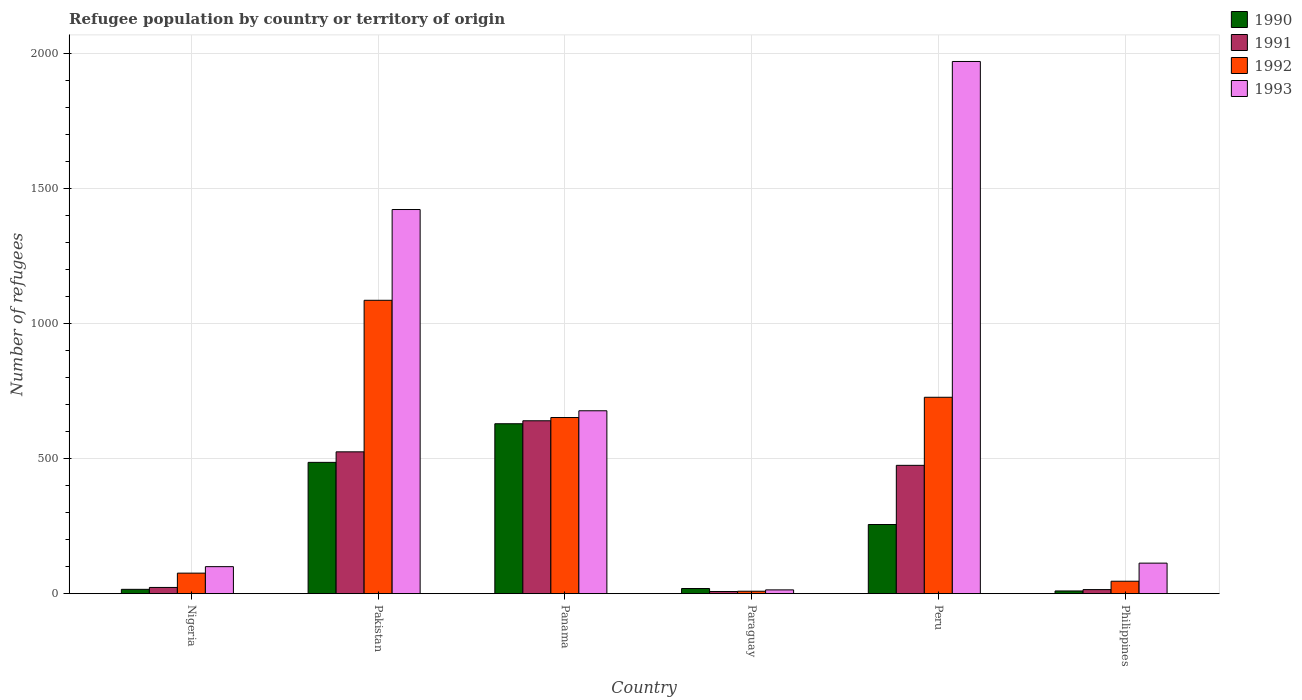How many bars are there on the 5th tick from the left?
Your answer should be very brief. 4. In how many cases, is the number of bars for a given country not equal to the number of legend labels?
Your answer should be very brief. 0. Across all countries, what is the maximum number of refugees in 1993?
Your answer should be compact. 1970. In which country was the number of refugees in 1992 maximum?
Make the answer very short. Pakistan. In which country was the number of refugees in 1993 minimum?
Keep it short and to the point. Paraguay. What is the total number of refugees in 1993 in the graph?
Your answer should be compact. 4296. What is the difference between the number of refugees in 1990 in Paraguay and that in Philippines?
Keep it short and to the point. 9. What is the difference between the number of refugees in 1991 in Panama and the number of refugees in 1993 in Nigeria?
Keep it short and to the point. 540. What is the average number of refugees in 1993 per country?
Your answer should be very brief. 716. What is the difference between the number of refugees of/in 1990 and number of refugees of/in 1992 in Pakistan?
Ensure brevity in your answer.  -600. In how many countries, is the number of refugees in 1992 greater than 600?
Offer a very short reply. 3. What is the ratio of the number of refugees in 1990 in Peru to that in Philippines?
Provide a succinct answer. 25.6. Is the number of refugees in 1993 in Nigeria less than that in Paraguay?
Give a very brief answer. No. Is the difference between the number of refugees in 1990 in Peru and Philippines greater than the difference between the number of refugees in 1992 in Peru and Philippines?
Your answer should be very brief. No. What is the difference between the highest and the second highest number of refugees in 1992?
Your response must be concise. -434. What is the difference between the highest and the lowest number of refugees in 1992?
Offer a very short reply. 1077. Is the sum of the number of refugees in 1993 in Nigeria and Peru greater than the maximum number of refugees in 1990 across all countries?
Your answer should be very brief. Yes. How many bars are there?
Your answer should be very brief. 24. Are all the bars in the graph horizontal?
Your response must be concise. No. Are the values on the major ticks of Y-axis written in scientific E-notation?
Your response must be concise. No. Does the graph contain grids?
Give a very brief answer. Yes. How many legend labels are there?
Offer a terse response. 4. How are the legend labels stacked?
Your answer should be very brief. Vertical. What is the title of the graph?
Keep it short and to the point. Refugee population by country or territory of origin. Does "1999" appear as one of the legend labels in the graph?
Provide a short and direct response. No. What is the label or title of the X-axis?
Ensure brevity in your answer.  Country. What is the label or title of the Y-axis?
Ensure brevity in your answer.  Number of refugees. What is the Number of refugees of 1990 in Nigeria?
Your answer should be very brief. 16. What is the Number of refugees of 1992 in Nigeria?
Ensure brevity in your answer.  76. What is the Number of refugees of 1993 in Nigeria?
Give a very brief answer. 100. What is the Number of refugees of 1990 in Pakistan?
Your answer should be compact. 486. What is the Number of refugees of 1991 in Pakistan?
Ensure brevity in your answer.  525. What is the Number of refugees in 1992 in Pakistan?
Give a very brief answer. 1086. What is the Number of refugees in 1993 in Pakistan?
Your response must be concise. 1422. What is the Number of refugees of 1990 in Panama?
Give a very brief answer. 629. What is the Number of refugees of 1991 in Panama?
Offer a terse response. 640. What is the Number of refugees of 1992 in Panama?
Your answer should be very brief. 652. What is the Number of refugees of 1993 in Panama?
Provide a succinct answer. 677. What is the Number of refugees in 1991 in Paraguay?
Give a very brief answer. 8. What is the Number of refugees in 1993 in Paraguay?
Your answer should be compact. 14. What is the Number of refugees of 1990 in Peru?
Keep it short and to the point. 256. What is the Number of refugees of 1991 in Peru?
Your response must be concise. 475. What is the Number of refugees of 1992 in Peru?
Your answer should be compact. 727. What is the Number of refugees of 1993 in Peru?
Make the answer very short. 1970. What is the Number of refugees of 1990 in Philippines?
Make the answer very short. 10. What is the Number of refugees in 1991 in Philippines?
Keep it short and to the point. 15. What is the Number of refugees of 1992 in Philippines?
Provide a short and direct response. 46. What is the Number of refugees of 1993 in Philippines?
Give a very brief answer. 113. Across all countries, what is the maximum Number of refugees of 1990?
Provide a succinct answer. 629. Across all countries, what is the maximum Number of refugees in 1991?
Your response must be concise. 640. Across all countries, what is the maximum Number of refugees of 1992?
Ensure brevity in your answer.  1086. Across all countries, what is the maximum Number of refugees of 1993?
Your answer should be very brief. 1970. Across all countries, what is the minimum Number of refugees in 1991?
Your answer should be very brief. 8. What is the total Number of refugees of 1990 in the graph?
Your response must be concise. 1416. What is the total Number of refugees in 1991 in the graph?
Your answer should be very brief. 1686. What is the total Number of refugees in 1992 in the graph?
Your answer should be very brief. 2596. What is the total Number of refugees in 1993 in the graph?
Your response must be concise. 4296. What is the difference between the Number of refugees in 1990 in Nigeria and that in Pakistan?
Your answer should be very brief. -470. What is the difference between the Number of refugees in 1991 in Nigeria and that in Pakistan?
Ensure brevity in your answer.  -502. What is the difference between the Number of refugees of 1992 in Nigeria and that in Pakistan?
Give a very brief answer. -1010. What is the difference between the Number of refugees of 1993 in Nigeria and that in Pakistan?
Offer a very short reply. -1322. What is the difference between the Number of refugees of 1990 in Nigeria and that in Panama?
Your answer should be compact. -613. What is the difference between the Number of refugees in 1991 in Nigeria and that in Panama?
Provide a succinct answer. -617. What is the difference between the Number of refugees of 1992 in Nigeria and that in Panama?
Provide a short and direct response. -576. What is the difference between the Number of refugees in 1993 in Nigeria and that in Panama?
Provide a succinct answer. -577. What is the difference between the Number of refugees in 1991 in Nigeria and that in Paraguay?
Keep it short and to the point. 15. What is the difference between the Number of refugees of 1992 in Nigeria and that in Paraguay?
Ensure brevity in your answer.  67. What is the difference between the Number of refugees in 1993 in Nigeria and that in Paraguay?
Provide a succinct answer. 86. What is the difference between the Number of refugees of 1990 in Nigeria and that in Peru?
Your answer should be very brief. -240. What is the difference between the Number of refugees in 1991 in Nigeria and that in Peru?
Make the answer very short. -452. What is the difference between the Number of refugees of 1992 in Nigeria and that in Peru?
Your answer should be compact. -651. What is the difference between the Number of refugees of 1993 in Nigeria and that in Peru?
Provide a succinct answer. -1870. What is the difference between the Number of refugees of 1990 in Nigeria and that in Philippines?
Provide a succinct answer. 6. What is the difference between the Number of refugees of 1990 in Pakistan and that in Panama?
Offer a very short reply. -143. What is the difference between the Number of refugees of 1991 in Pakistan and that in Panama?
Your response must be concise. -115. What is the difference between the Number of refugees in 1992 in Pakistan and that in Panama?
Offer a terse response. 434. What is the difference between the Number of refugees of 1993 in Pakistan and that in Panama?
Keep it short and to the point. 745. What is the difference between the Number of refugees in 1990 in Pakistan and that in Paraguay?
Offer a terse response. 467. What is the difference between the Number of refugees of 1991 in Pakistan and that in Paraguay?
Offer a terse response. 517. What is the difference between the Number of refugees in 1992 in Pakistan and that in Paraguay?
Give a very brief answer. 1077. What is the difference between the Number of refugees in 1993 in Pakistan and that in Paraguay?
Provide a succinct answer. 1408. What is the difference between the Number of refugees in 1990 in Pakistan and that in Peru?
Your answer should be compact. 230. What is the difference between the Number of refugees of 1992 in Pakistan and that in Peru?
Give a very brief answer. 359. What is the difference between the Number of refugees in 1993 in Pakistan and that in Peru?
Offer a very short reply. -548. What is the difference between the Number of refugees of 1990 in Pakistan and that in Philippines?
Your answer should be very brief. 476. What is the difference between the Number of refugees in 1991 in Pakistan and that in Philippines?
Give a very brief answer. 510. What is the difference between the Number of refugees in 1992 in Pakistan and that in Philippines?
Your answer should be compact. 1040. What is the difference between the Number of refugees in 1993 in Pakistan and that in Philippines?
Make the answer very short. 1309. What is the difference between the Number of refugees of 1990 in Panama and that in Paraguay?
Your answer should be very brief. 610. What is the difference between the Number of refugees in 1991 in Panama and that in Paraguay?
Offer a terse response. 632. What is the difference between the Number of refugees of 1992 in Panama and that in Paraguay?
Offer a very short reply. 643. What is the difference between the Number of refugees in 1993 in Panama and that in Paraguay?
Make the answer very short. 663. What is the difference between the Number of refugees of 1990 in Panama and that in Peru?
Your answer should be compact. 373. What is the difference between the Number of refugees in 1991 in Panama and that in Peru?
Offer a terse response. 165. What is the difference between the Number of refugees of 1992 in Panama and that in Peru?
Provide a short and direct response. -75. What is the difference between the Number of refugees of 1993 in Panama and that in Peru?
Offer a terse response. -1293. What is the difference between the Number of refugees of 1990 in Panama and that in Philippines?
Provide a short and direct response. 619. What is the difference between the Number of refugees in 1991 in Panama and that in Philippines?
Provide a short and direct response. 625. What is the difference between the Number of refugees in 1992 in Panama and that in Philippines?
Offer a terse response. 606. What is the difference between the Number of refugees in 1993 in Panama and that in Philippines?
Offer a very short reply. 564. What is the difference between the Number of refugees of 1990 in Paraguay and that in Peru?
Ensure brevity in your answer.  -237. What is the difference between the Number of refugees in 1991 in Paraguay and that in Peru?
Offer a very short reply. -467. What is the difference between the Number of refugees in 1992 in Paraguay and that in Peru?
Provide a short and direct response. -718. What is the difference between the Number of refugees of 1993 in Paraguay and that in Peru?
Offer a very short reply. -1956. What is the difference between the Number of refugees of 1990 in Paraguay and that in Philippines?
Offer a very short reply. 9. What is the difference between the Number of refugees of 1992 in Paraguay and that in Philippines?
Offer a very short reply. -37. What is the difference between the Number of refugees of 1993 in Paraguay and that in Philippines?
Your answer should be compact. -99. What is the difference between the Number of refugees of 1990 in Peru and that in Philippines?
Give a very brief answer. 246. What is the difference between the Number of refugees in 1991 in Peru and that in Philippines?
Provide a short and direct response. 460. What is the difference between the Number of refugees of 1992 in Peru and that in Philippines?
Your answer should be very brief. 681. What is the difference between the Number of refugees of 1993 in Peru and that in Philippines?
Provide a succinct answer. 1857. What is the difference between the Number of refugees in 1990 in Nigeria and the Number of refugees in 1991 in Pakistan?
Your answer should be compact. -509. What is the difference between the Number of refugees of 1990 in Nigeria and the Number of refugees of 1992 in Pakistan?
Keep it short and to the point. -1070. What is the difference between the Number of refugees in 1990 in Nigeria and the Number of refugees in 1993 in Pakistan?
Your response must be concise. -1406. What is the difference between the Number of refugees of 1991 in Nigeria and the Number of refugees of 1992 in Pakistan?
Give a very brief answer. -1063. What is the difference between the Number of refugees of 1991 in Nigeria and the Number of refugees of 1993 in Pakistan?
Ensure brevity in your answer.  -1399. What is the difference between the Number of refugees in 1992 in Nigeria and the Number of refugees in 1993 in Pakistan?
Offer a very short reply. -1346. What is the difference between the Number of refugees of 1990 in Nigeria and the Number of refugees of 1991 in Panama?
Provide a short and direct response. -624. What is the difference between the Number of refugees in 1990 in Nigeria and the Number of refugees in 1992 in Panama?
Ensure brevity in your answer.  -636. What is the difference between the Number of refugees in 1990 in Nigeria and the Number of refugees in 1993 in Panama?
Your response must be concise. -661. What is the difference between the Number of refugees of 1991 in Nigeria and the Number of refugees of 1992 in Panama?
Offer a terse response. -629. What is the difference between the Number of refugees in 1991 in Nigeria and the Number of refugees in 1993 in Panama?
Ensure brevity in your answer.  -654. What is the difference between the Number of refugees in 1992 in Nigeria and the Number of refugees in 1993 in Panama?
Your answer should be compact. -601. What is the difference between the Number of refugees of 1990 in Nigeria and the Number of refugees of 1991 in Paraguay?
Your answer should be compact. 8. What is the difference between the Number of refugees in 1990 in Nigeria and the Number of refugees in 1992 in Paraguay?
Offer a very short reply. 7. What is the difference between the Number of refugees of 1991 in Nigeria and the Number of refugees of 1992 in Paraguay?
Offer a very short reply. 14. What is the difference between the Number of refugees of 1990 in Nigeria and the Number of refugees of 1991 in Peru?
Ensure brevity in your answer.  -459. What is the difference between the Number of refugees in 1990 in Nigeria and the Number of refugees in 1992 in Peru?
Provide a succinct answer. -711. What is the difference between the Number of refugees of 1990 in Nigeria and the Number of refugees of 1993 in Peru?
Your answer should be very brief. -1954. What is the difference between the Number of refugees of 1991 in Nigeria and the Number of refugees of 1992 in Peru?
Keep it short and to the point. -704. What is the difference between the Number of refugees in 1991 in Nigeria and the Number of refugees in 1993 in Peru?
Make the answer very short. -1947. What is the difference between the Number of refugees of 1992 in Nigeria and the Number of refugees of 1993 in Peru?
Provide a short and direct response. -1894. What is the difference between the Number of refugees in 1990 in Nigeria and the Number of refugees in 1991 in Philippines?
Offer a very short reply. 1. What is the difference between the Number of refugees of 1990 in Nigeria and the Number of refugees of 1993 in Philippines?
Your response must be concise. -97. What is the difference between the Number of refugees in 1991 in Nigeria and the Number of refugees in 1993 in Philippines?
Your answer should be very brief. -90. What is the difference between the Number of refugees in 1992 in Nigeria and the Number of refugees in 1993 in Philippines?
Offer a very short reply. -37. What is the difference between the Number of refugees of 1990 in Pakistan and the Number of refugees of 1991 in Panama?
Provide a short and direct response. -154. What is the difference between the Number of refugees in 1990 in Pakistan and the Number of refugees in 1992 in Panama?
Provide a succinct answer. -166. What is the difference between the Number of refugees of 1990 in Pakistan and the Number of refugees of 1993 in Panama?
Your answer should be very brief. -191. What is the difference between the Number of refugees of 1991 in Pakistan and the Number of refugees of 1992 in Panama?
Offer a terse response. -127. What is the difference between the Number of refugees of 1991 in Pakistan and the Number of refugees of 1993 in Panama?
Ensure brevity in your answer.  -152. What is the difference between the Number of refugees in 1992 in Pakistan and the Number of refugees in 1993 in Panama?
Provide a short and direct response. 409. What is the difference between the Number of refugees in 1990 in Pakistan and the Number of refugees in 1991 in Paraguay?
Your response must be concise. 478. What is the difference between the Number of refugees of 1990 in Pakistan and the Number of refugees of 1992 in Paraguay?
Your answer should be very brief. 477. What is the difference between the Number of refugees of 1990 in Pakistan and the Number of refugees of 1993 in Paraguay?
Your answer should be very brief. 472. What is the difference between the Number of refugees in 1991 in Pakistan and the Number of refugees in 1992 in Paraguay?
Provide a short and direct response. 516. What is the difference between the Number of refugees of 1991 in Pakistan and the Number of refugees of 1993 in Paraguay?
Ensure brevity in your answer.  511. What is the difference between the Number of refugees in 1992 in Pakistan and the Number of refugees in 1993 in Paraguay?
Your answer should be compact. 1072. What is the difference between the Number of refugees of 1990 in Pakistan and the Number of refugees of 1991 in Peru?
Offer a terse response. 11. What is the difference between the Number of refugees in 1990 in Pakistan and the Number of refugees in 1992 in Peru?
Your answer should be very brief. -241. What is the difference between the Number of refugees in 1990 in Pakistan and the Number of refugees in 1993 in Peru?
Offer a terse response. -1484. What is the difference between the Number of refugees of 1991 in Pakistan and the Number of refugees of 1992 in Peru?
Your answer should be compact. -202. What is the difference between the Number of refugees in 1991 in Pakistan and the Number of refugees in 1993 in Peru?
Offer a terse response. -1445. What is the difference between the Number of refugees of 1992 in Pakistan and the Number of refugees of 1993 in Peru?
Your answer should be very brief. -884. What is the difference between the Number of refugees of 1990 in Pakistan and the Number of refugees of 1991 in Philippines?
Provide a succinct answer. 471. What is the difference between the Number of refugees of 1990 in Pakistan and the Number of refugees of 1992 in Philippines?
Your answer should be compact. 440. What is the difference between the Number of refugees of 1990 in Pakistan and the Number of refugees of 1993 in Philippines?
Your answer should be very brief. 373. What is the difference between the Number of refugees in 1991 in Pakistan and the Number of refugees in 1992 in Philippines?
Give a very brief answer. 479. What is the difference between the Number of refugees of 1991 in Pakistan and the Number of refugees of 1993 in Philippines?
Your response must be concise. 412. What is the difference between the Number of refugees of 1992 in Pakistan and the Number of refugees of 1993 in Philippines?
Offer a terse response. 973. What is the difference between the Number of refugees of 1990 in Panama and the Number of refugees of 1991 in Paraguay?
Offer a terse response. 621. What is the difference between the Number of refugees of 1990 in Panama and the Number of refugees of 1992 in Paraguay?
Provide a short and direct response. 620. What is the difference between the Number of refugees of 1990 in Panama and the Number of refugees of 1993 in Paraguay?
Your answer should be compact. 615. What is the difference between the Number of refugees in 1991 in Panama and the Number of refugees in 1992 in Paraguay?
Keep it short and to the point. 631. What is the difference between the Number of refugees in 1991 in Panama and the Number of refugees in 1993 in Paraguay?
Keep it short and to the point. 626. What is the difference between the Number of refugees of 1992 in Panama and the Number of refugees of 1993 in Paraguay?
Keep it short and to the point. 638. What is the difference between the Number of refugees in 1990 in Panama and the Number of refugees in 1991 in Peru?
Offer a terse response. 154. What is the difference between the Number of refugees of 1990 in Panama and the Number of refugees of 1992 in Peru?
Keep it short and to the point. -98. What is the difference between the Number of refugees of 1990 in Panama and the Number of refugees of 1993 in Peru?
Your answer should be very brief. -1341. What is the difference between the Number of refugees of 1991 in Panama and the Number of refugees of 1992 in Peru?
Provide a succinct answer. -87. What is the difference between the Number of refugees of 1991 in Panama and the Number of refugees of 1993 in Peru?
Make the answer very short. -1330. What is the difference between the Number of refugees in 1992 in Panama and the Number of refugees in 1993 in Peru?
Provide a succinct answer. -1318. What is the difference between the Number of refugees in 1990 in Panama and the Number of refugees in 1991 in Philippines?
Your answer should be compact. 614. What is the difference between the Number of refugees of 1990 in Panama and the Number of refugees of 1992 in Philippines?
Make the answer very short. 583. What is the difference between the Number of refugees in 1990 in Panama and the Number of refugees in 1993 in Philippines?
Provide a short and direct response. 516. What is the difference between the Number of refugees of 1991 in Panama and the Number of refugees of 1992 in Philippines?
Make the answer very short. 594. What is the difference between the Number of refugees in 1991 in Panama and the Number of refugees in 1993 in Philippines?
Provide a short and direct response. 527. What is the difference between the Number of refugees of 1992 in Panama and the Number of refugees of 1993 in Philippines?
Offer a terse response. 539. What is the difference between the Number of refugees of 1990 in Paraguay and the Number of refugees of 1991 in Peru?
Your answer should be compact. -456. What is the difference between the Number of refugees in 1990 in Paraguay and the Number of refugees in 1992 in Peru?
Provide a short and direct response. -708. What is the difference between the Number of refugees in 1990 in Paraguay and the Number of refugees in 1993 in Peru?
Give a very brief answer. -1951. What is the difference between the Number of refugees in 1991 in Paraguay and the Number of refugees in 1992 in Peru?
Your answer should be very brief. -719. What is the difference between the Number of refugees of 1991 in Paraguay and the Number of refugees of 1993 in Peru?
Make the answer very short. -1962. What is the difference between the Number of refugees of 1992 in Paraguay and the Number of refugees of 1993 in Peru?
Your answer should be very brief. -1961. What is the difference between the Number of refugees of 1990 in Paraguay and the Number of refugees of 1993 in Philippines?
Make the answer very short. -94. What is the difference between the Number of refugees of 1991 in Paraguay and the Number of refugees of 1992 in Philippines?
Make the answer very short. -38. What is the difference between the Number of refugees of 1991 in Paraguay and the Number of refugees of 1993 in Philippines?
Your response must be concise. -105. What is the difference between the Number of refugees of 1992 in Paraguay and the Number of refugees of 1993 in Philippines?
Offer a very short reply. -104. What is the difference between the Number of refugees in 1990 in Peru and the Number of refugees in 1991 in Philippines?
Keep it short and to the point. 241. What is the difference between the Number of refugees of 1990 in Peru and the Number of refugees of 1992 in Philippines?
Your answer should be very brief. 210. What is the difference between the Number of refugees in 1990 in Peru and the Number of refugees in 1993 in Philippines?
Offer a very short reply. 143. What is the difference between the Number of refugees of 1991 in Peru and the Number of refugees of 1992 in Philippines?
Your answer should be compact. 429. What is the difference between the Number of refugees of 1991 in Peru and the Number of refugees of 1993 in Philippines?
Offer a very short reply. 362. What is the difference between the Number of refugees of 1992 in Peru and the Number of refugees of 1993 in Philippines?
Offer a very short reply. 614. What is the average Number of refugees in 1990 per country?
Keep it short and to the point. 236. What is the average Number of refugees in 1991 per country?
Ensure brevity in your answer.  281. What is the average Number of refugees of 1992 per country?
Offer a very short reply. 432.67. What is the average Number of refugees in 1993 per country?
Give a very brief answer. 716. What is the difference between the Number of refugees in 1990 and Number of refugees in 1992 in Nigeria?
Your answer should be compact. -60. What is the difference between the Number of refugees of 1990 and Number of refugees of 1993 in Nigeria?
Provide a succinct answer. -84. What is the difference between the Number of refugees of 1991 and Number of refugees of 1992 in Nigeria?
Your answer should be very brief. -53. What is the difference between the Number of refugees in 1991 and Number of refugees in 1993 in Nigeria?
Ensure brevity in your answer.  -77. What is the difference between the Number of refugees in 1990 and Number of refugees in 1991 in Pakistan?
Make the answer very short. -39. What is the difference between the Number of refugees of 1990 and Number of refugees of 1992 in Pakistan?
Give a very brief answer. -600. What is the difference between the Number of refugees in 1990 and Number of refugees in 1993 in Pakistan?
Keep it short and to the point. -936. What is the difference between the Number of refugees in 1991 and Number of refugees in 1992 in Pakistan?
Offer a terse response. -561. What is the difference between the Number of refugees of 1991 and Number of refugees of 1993 in Pakistan?
Keep it short and to the point. -897. What is the difference between the Number of refugees of 1992 and Number of refugees of 1993 in Pakistan?
Your response must be concise. -336. What is the difference between the Number of refugees in 1990 and Number of refugees in 1993 in Panama?
Ensure brevity in your answer.  -48. What is the difference between the Number of refugees in 1991 and Number of refugees in 1993 in Panama?
Ensure brevity in your answer.  -37. What is the difference between the Number of refugees of 1992 and Number of refugees of 1993 in Panama?
Your answer should be compact. -25. What is the difference between the Number of refugees of 1990 and Number of refugees of 1993 in Paraguay?
Give a very brief answer. 5. What is the difference between the Number of refugees in 1991 and Number of refugees in 1993 in Paraguay?
Keep it short and to the point. -6. What is the difference between the Number of refugees in 1990 and Number of refugees in 1991 in Peru?
Ensure brevity in your answer.  -219. What is the difference between the Number of refugees in 1990 and Number of refugees in 1992 in Peru?
Provide a short and direct response. -471. What is the difference between the Number of refugees in 1990 and Number of refugees in 1993 in Peru?
Your answer should be very brief. -1714. What is the difference between the Number of refugees of 1991 and Number of refugees of 1992 in Peru?
Make the answer very short. -252. What is the difference between the Number of refugees in 1991 and Number of refugees in 1993 in Peru?
Make the answer very short. -1495. What is the difference between the Number of refugees in 1992 and Number of refugees in 1993 in Peru?
Give a very brief answer. -1243. What is the difference between the Number of refugees in 1990 and Number of refugees in 1992 in Philippines?
Your answer should be compact. -36. What is the difference between the Number of refugees of 1990 and Number of refugees of 1993 in Philippines?
Keep it short and to the point. -103. What is the difference between the Number of refugees of 1991 and Number of refugees of 1992 in Philippines?
Offer a very short reply. -31. What is the difference between the Number of refugees in 1991 and Number of refugees in 1993 in Philippines?
Provide a short and direct response. -98. What is the difference between the Number of refugees in 1992 and Number of refugees in 1993 in Philippines?
Provide a short and direct response. -67. What is the ratio of the Number of refugees in 1990 in Nigeria to that in Pakistan?
Provide a short and direct response. 0.03. What is the ratio of the Number of refugees of 1991 in Nigeria to that in Pakistan?
Ensure brevity in your answer.  0.04. What is the ratio of the Number of refugees in 1992 in Nigeria to that in Pakistan?
Your answer should be very brief. 0.07. What is the ratio of the Number of refugees of 1993 in Nigeria to that in Pakistan?
Your answer should be compact. 0.07. What is the ratio of the Number of refugees of 1990 in Nigeria to that in Panama?
Ensure brevity in your answer.  0.03. What is the ratio of the Number of refugees in 1991 in Nigeria to that in Panama?
Make the answer very short. 0.04. What is the ratio of the Number of refugees in 1992 in Nigeria to that in Panama?
Provide a short and direct response. 0.12. What is the ratio of the Number of refugees in 1993 in Nigeria to that in Panama?
Your answer should be compact. 0.15. What is the ratio of the Number of refugees of 1990 in Nigeria to that in Paraguay?
Offer a terse response. 0.84. What is the ratio of the Number of refugees in 1991 in Nigeria to that in Paraguay?
Make the answer very short. 2.88. What is the ratio of the Number of refugees of 1992 in Nigeria to that in Paraguay?
Your response must be concise. 8.44. What is the ratio of the Number of refugees in 1993 in Nigeria to that in Paraguay?
Give a very brief answer. 7.14. What is the ratio of the Number of refugees in 1990 in Nigeria to that in Peru?
Keep it short and to the point. 0.06. What is the ratio of the Number of refugees of 1991 in Nigeria to that in Peru?
Give a very brief answer. 0.05. What is the ratio of the Number of refugees in 1992 in Nigeria to that in Peru?
Give a very brief answer. 0.1. What is the ratio of the Number of refugees of 1993 in Nigeria to that in Peru?
Provide a succinct answer. 0.05. What is the ratio of the Number of refugees in 1991 in Nigeria to that in Philippines?
Give a very brief answer. 1.53. What is the ratio of the Number of refugees in 1992 in Nigeria to that in Philippines?
Give a very brief answer. 1.65. What is the ratio of the Number of refugees in 1993 in Nigeria to that in Philippines?
Give a very brief answer. 0.89. What is the ratio of the Number of refugees of 1990 in Pakistan to that in Panama?
Your answer should be very brief. 0.77. What is the ratio of the Number of refugees of 1991 in Pakistan to that in Panama?
Make the answer very short. 0.82. What is the ratio of the Number of refugees of 1992 in Pakistan to that in Panama?
Give a very brief answer. 1.67. What is the ratio of the Number of refugees of 1993 in Pakistan to that in Panama?
Your answer should be very brief. 2.1. What is the ratio of the Number of refugees of 1990 in Pakistan to that in Paraguay?
Make the answer very short. 25.58. What is the ratio of the Number of refugees of 1991 in Pakistan to that in Paraguay?
Make the answer very short. 65.62. What is the ratio of the Number of refugees in 1992 in Pakistan to that in Paraguay?
Your answer should be compact. 120.67. What is the ratio of the Number of refugees in 1993 in Pakistan to that in Paraguay?
Offer a terse response. 101.57. What is the ratio of the Number of refugees of 1990 in Pakistan to that in Peru?
Keep it short and to the point. 1.9. What is the ratio of the Number of refugees in 1991 in Pakistan to that in Peru?
Your answer should be very brief. 1.11. What is the ratio of the Number of refugees in 1992 in Pakistan to that in Peru?
Provide a short and direct response. 1.49. What is the ratio of the Number of refugees of 1993 in Pakistan to that in Peru?
Provide a short and direct response. 0.72. What is the ratio of the Number of refugees in 1990 in Pakistan to that in Philippines?
Ensure brevity in your answer.  48.6. What is the ratio of the Number of refugees in 1992 in Pakistan to that in Philippines?
Ensure brevity in your answer.  23.61. What is the ratio of the Number of refugees of 1993 in Pakistan to that in Philippines?
Your response must be concise. 12.58. What is the ratio of the Number of refugees in 1990 in Panama to that in Paraguay?
Give a very brief answer. 33.11. What is the ratio of the Number of refugees in 1992 in Panama to that in Paraguay?
Your answer should be compact. 72.44. What is the ratio of the Number of refugees of 1993 in Panama to that in Paraguay?
Ensure brevity in your answer.  48.36. What is the ratio of the Number of refugees in 1990 in Panama to that in Peru?
Provide a succinct answer. 2.46. What is the ratio of the Number of refugees of 1991 in Panama to that in Peru?
Make the answer very short. 1.35. What is the ratio of the Number of refugees of 1992 in Panama to that in Peru?
Provide a short and direct response. 0.9. What is the ratio of the Number of refugees of 1993 in Panama to that in Peru?
Provide a short and direct response. 0.34. What is the ratio of the Number of refugees of 1990 in Panama to that in Philippines?
Keep it short and to the point. 62.9. What is the ratio of the Number of refugees in 1991 in Panama to that in Philippines?
Offer a very short reply. 42.67. What is the ratio of the Number of refugees in 1992 in Panama to that in Philippines?
Your answer should be compact. 14.17. What is the ratio of the Number of refugees in 1993 in Panama to that in Philippines?
Keep it short and to the point. 5.99. What is the ratio of the Number of refugees of 1990 in Paraguay to that in Peru?
Make the answer very short. 0.07. What is the ratio of the Number of refugees of 1991 in Paraguay to that in Peru?
Your response must be concise. 0.02. What is the ratio of the Number of refugees of 1992 in Paraguay to that in Peru?
Make the answer very short. 0.01. What is the ratio of the Number of refugees in 1993 in Paraguay to that in Peru?
Give a very brief answer. 0.01. What is the ratio of the Number of refugees of 1990 in Paraguay to that in Philippines?
Ensure brevity in your answer.  1.9. What is the ratio of the Number of refugees of 1991 in Paraguay to that in Philippines?
Your response must be concise. 0.53. What is the ratio of the Number of refugees in 1992 in Paraguay to that in Philippines?
Make the answer very short. 0.2. What is the ratio of the Number of refugees of 1993 in Paraguay to that in Philippines?
Offer a terse response. 0.12. What is the ratio of the Number of refugees in 1990 in Peru to that in Philippines?
Offer a terse response. 25.6. What is the ratio of the Number of refugees in 1991 in Peru to that in Philippines?
Your response must be concise. 31.67. What is the ratio of the Number of refugees of 1992 in Peru to that in Philippines?
Your response must be concise. 15.8. What is the ratio of the Number of refugees in 1993 in Peru to that in Philippines?
Your response must be concise. 17.43. What is the difference between the highest and the second highest Number of refugees in 1990?
Provide a short and direct response. 143. What is the difference between the highest and the second highest Number of refugees of 1991?
Your answer should be very brief. 115. What is the difference between the highest and the second highest Number of refugees of 1992?
Provide a succinct answer. 359. What is the difference between the highest and the second highest Number of refugees in 1993?
Keep it short and to the point. 548. What is the difference between the highest and the lowest Number of refugees of 1990?
Keep it short and to the point. 619. What is the difference between the highest and the lowest Number of refugees in 1991?
Give a very brief answer. 632. What is the difference between the highest and the lowest Number of refugees of 1992?
Keep it short and to the point. 1077. What is the difference between the highest and the lowest Number of refugees in 1993?
Give a very brief answer. 1956. 